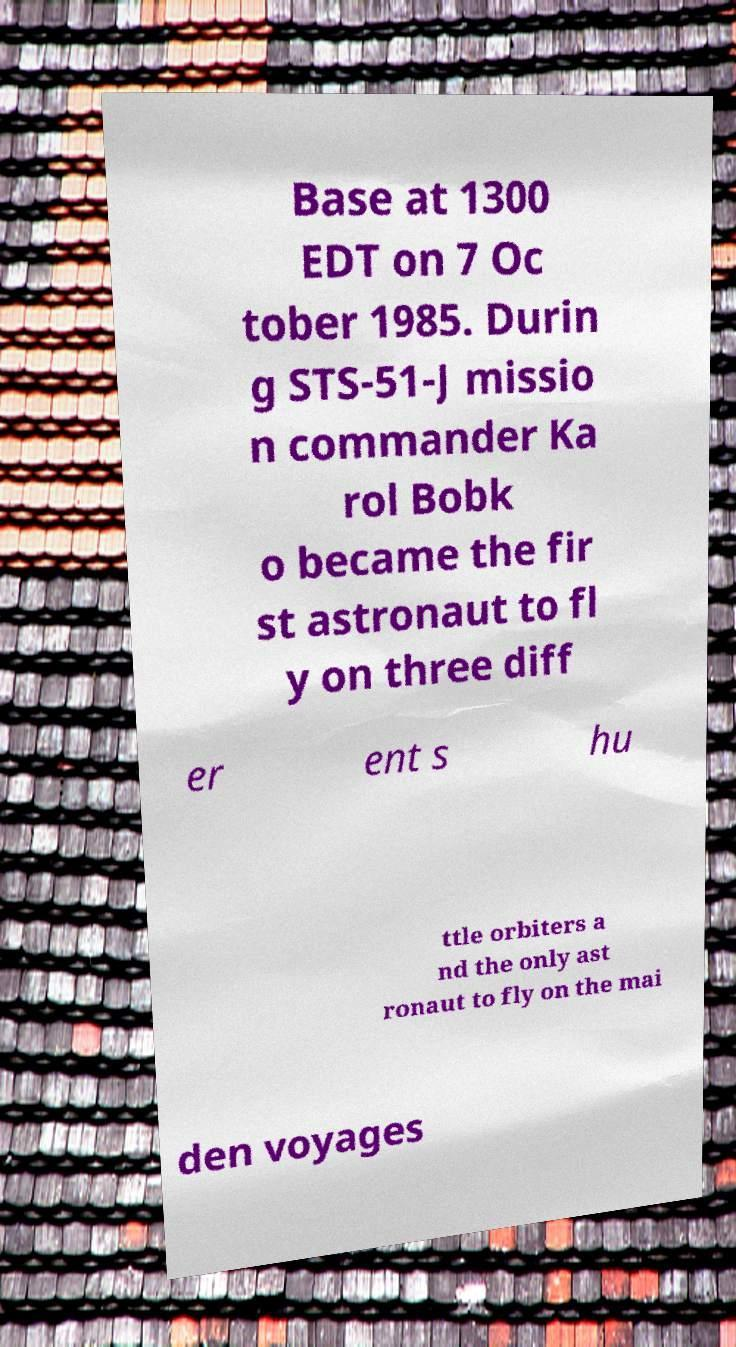Can you accurately transcribe the text from the provided image for me? Base at 1300 EDT on 7 Oc tober 1985. Durin g STS-51-J missio n commander Ka rol Bobk o became the fir st astronaut to fl y on three diff er ent s hu ttle orbiters a nd the only ast ronaut to fly on the mai den voyages 